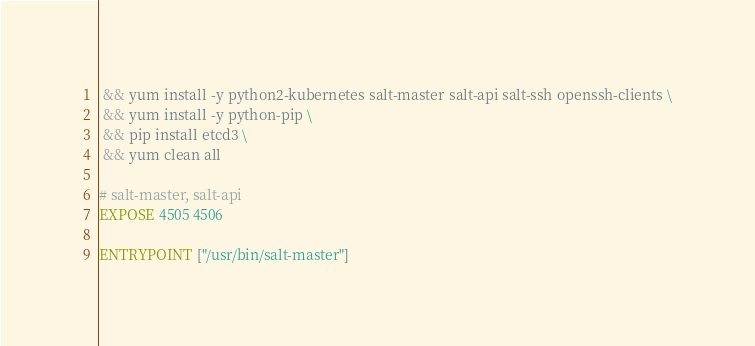Convert code to text. <code><loc_0><loc_0><loc_500><loc_500><_Dockerfile_> && yum install -y python2-kubernetes salt-master salt-api salt-ssh openssh-clients \
 && yum install -y python-pip \
 && pip install etcd3 \
 && yum clean all

# salt-master, salt-api
EXPOSE 4505 4506

ENTRYPOINT ["/usr/bin/salt-master"]
</code> 